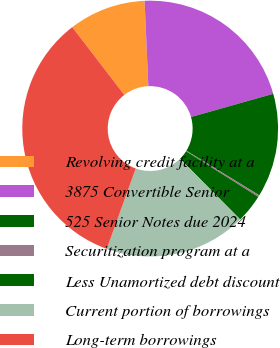<chart> <loc_0><loc_0><loc_500><loc_500><pie_chart><fcel>Revolving credit facility at a<fcel>3875 Convertible Senior<fcel>525 Senior Notes due 2024<fcel>Securitization program at a<fcel>Less Unamortized debt discount<fcel>Current portion of borrowings<fcel>Long-term borrowings<nl><fcel>9.73%<fcel>21.31%<fcel>13.12%<fcel>0.23%<fcel>3.61%<fcel>17.93%<fcel>34.07%<nl></chart> 